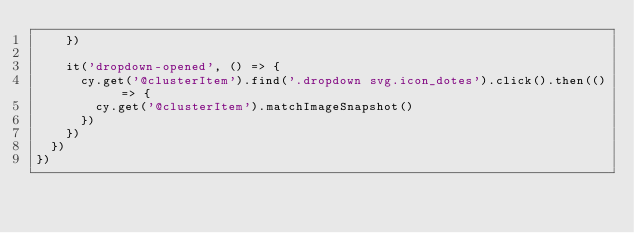Convert code to text. <code><loc_0><loc_0><loc_500><loc_500><_JavaScript_>    })

    it('dropdown-opened', () => {
      cy.get('@clusterItem').find('.dropdown svg.icon_dotes').click().then(() => {
        cy.get('@clusterItem').matchImageSnapshot()
      })
    })
  })
})
</code> 